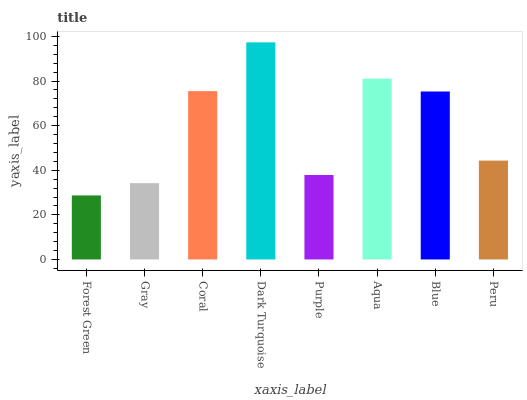Is Forest Green the minimum?
Answer yes or no. Yes. Is Dark Turquoise the maximum?
Answer yes or no. Yes. Is Gray the minimum?
Answer yes or no. No. Is Gray the maximum?
Answer yes or no. No. Is Gray greater than Forest Green?
Answer yes or no. Yes. Is Forest Green less than Gray?
Answer yes or no. Yes. Is Forest Green greater than Gray?
Answer yes or no. No. Is Gray less than Forest Green?
Answer yes or no. No. Is Blue the high median?
Answer yes or no. Yes. Is Peru the low median?
Answer yes or no. Yes. Is Purple the high median?
Answer yes or no. No. Is Forest Green the low median?
Answer yes or no. No. 